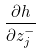Convert formula to latex. <formula><loc_0><loc_0><loc_500><loc_500>\frac { \partial h } { \partial z _ { j } ^ { - } }</formula> 